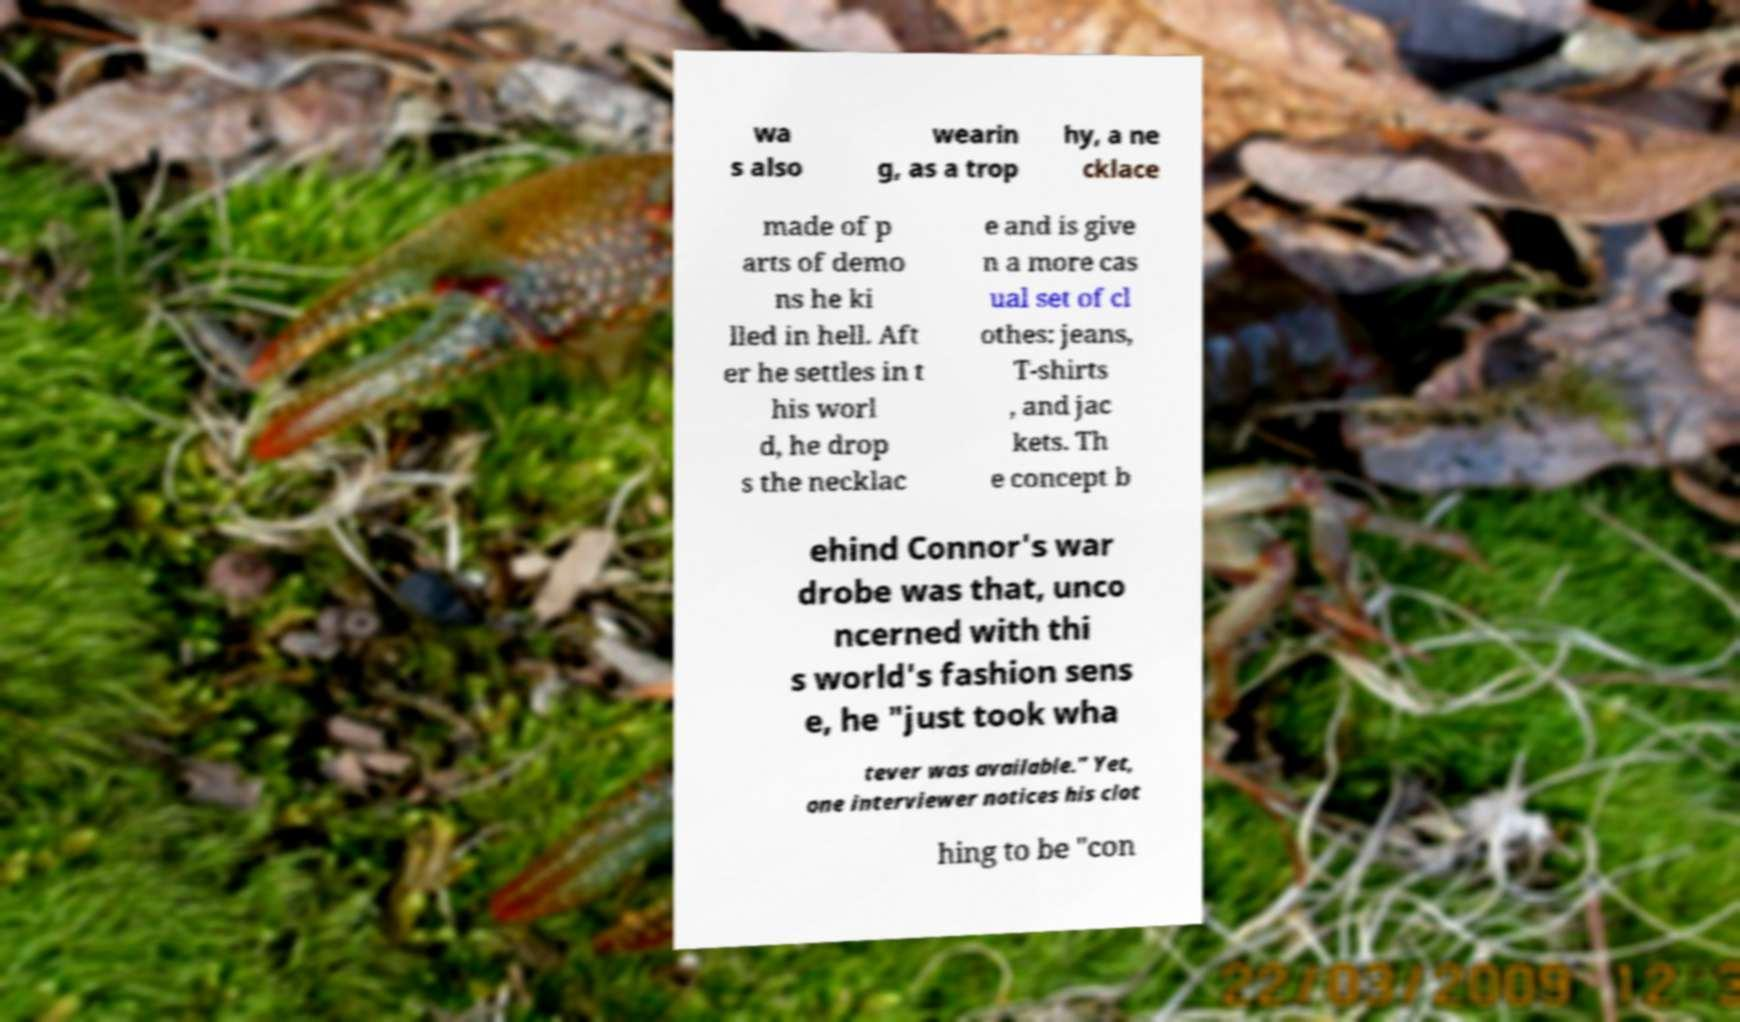Please identify and transcribe the text found in this image. wa s also wearin g, as a trop hy, a ne cklace made of p arts of demo ns he ki lled in hell. Aft er he settles in t his worl d, he drop s the necklac e and is give n a more cas ual set of cl othes: jeans, T-shirts , and jac kets. Th e concept b ehind Connor's war drobe was that, unco ncerned with thi s world's fashion sens e, he "just took wha tever was available." Yet, one interviewer notices his clot hing to be "con 